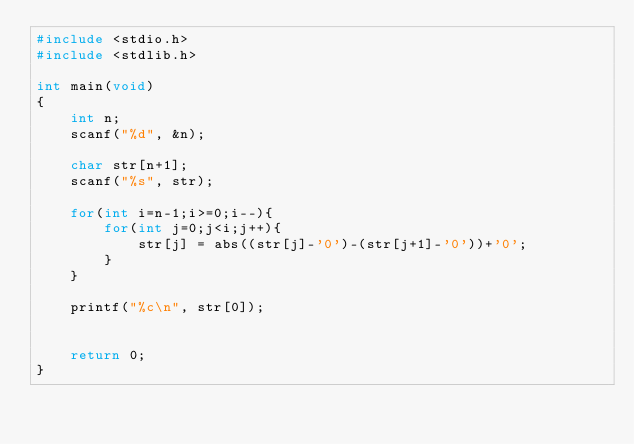<code> <loc_0><loc_0><loc_500><loc_500><_C_>#include <stdio.h>
#include <stdlib.h>

int main(void)
{
    int n;
    scanf("%d", &n);

    char str[n+1];
    scanf("%s", str);
    
    for(int i=n-1;i>=0;i--){
        for(int j=0;j<i;j++){
            str[j] = abs((str[j]-'0')-(str[j+1]-'0'))+'0';
        }
    }

    printf("%c\n", str[0]);

    
    return 0;
}</code> 